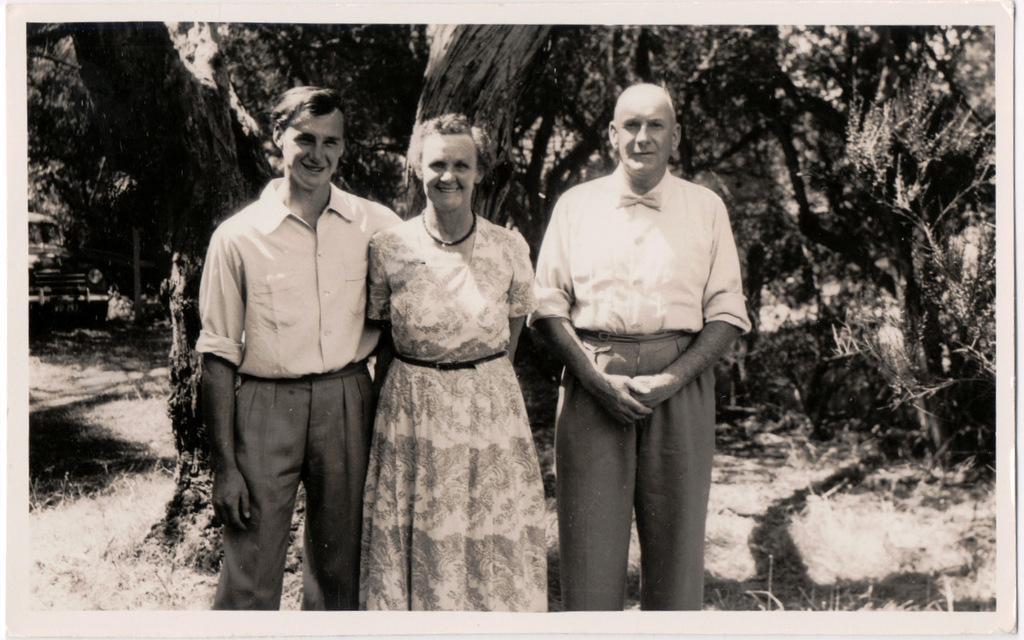Could you give a brief overview of what you see in this image? This is a black and white picture. Here we can see three persons and they are smiling. There is a car. In the background there are trees. 